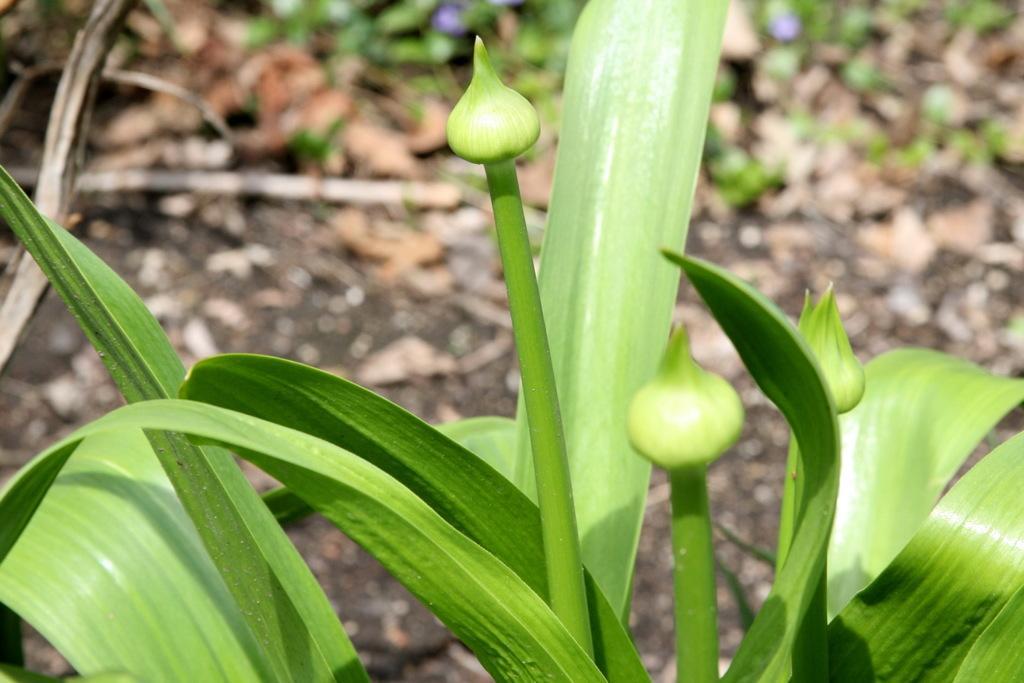Please provide a concise description of this image. In the image there are green color leaves with stems and buds. Behind them there is a blur background. 